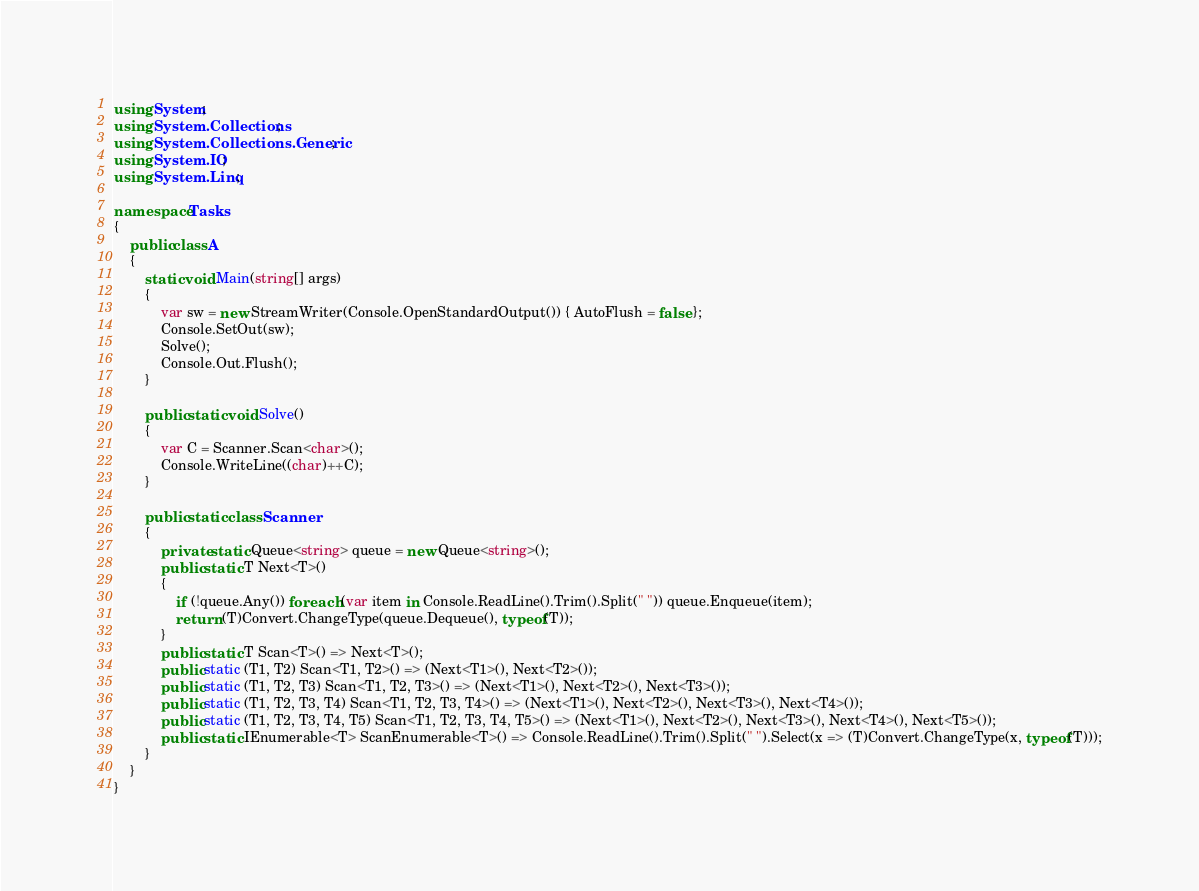<code> <loc_0><loc_0><loc_500><loc_500><_C#_>using System;
using System.Collections;
using System.Collections.Generic;
using System.IO;
using System.Linq;

namespace Tasks
{
    public class A
    {
        static void Main(string[] args)
        {
            var sw = new StreamWriter(Console.OpenStandardOutput()) { AutoFlush = false };
            Console.SetOut(sw);
            Solve();
            Console.Out.Flush();
        }

        public static void Solve()
        {
            var C = Scanner.Scan<char>();
            Console.WriteLine((char)++C);
        }

        public static class Scanner
        {
            private static Queue<string> queue = new Queue<string>();
            public static T Next<T>()
            {
                if (!queue.Any()) foreach (var item in Console.ReadLine().Trim().Split(" ")) queue.Enqueue(item);
                return (T)Convert.ChangeType(queue.Dequeue(), typeof(T));
            }
            public static T Scan<T>() => Next<T>();
            public static (T1, T2) Scan<T1, T2>() => (Next<T1>(), Next<T2>());
            public static (T1, T2, T3) Scan<T1, T2, T3>() => (Next<T1>(), Next<T2>(), Next<T3>());
            public static (T1, T2, T3, T4) Scan<T1, T2, T3, T4>() => (Next<T1>(), Next<T2>(), Next<T3>(), Next<T4>());
            public static (T1, T2, T3, T4, T5) Scan<T1, T2, T3, T4, T5>() => (Next<T1>(), Next<T2>(), Next<T3>(), Next<T4>(), Next<T5>());
            public static IEnumerable<T> ScanEnumerable<T>() => Console.ReadLine().Trim().Split(" ").Select(x => (T)Convert.ChangeType(x, typeof(T)));
        }
    }
}
</code> 